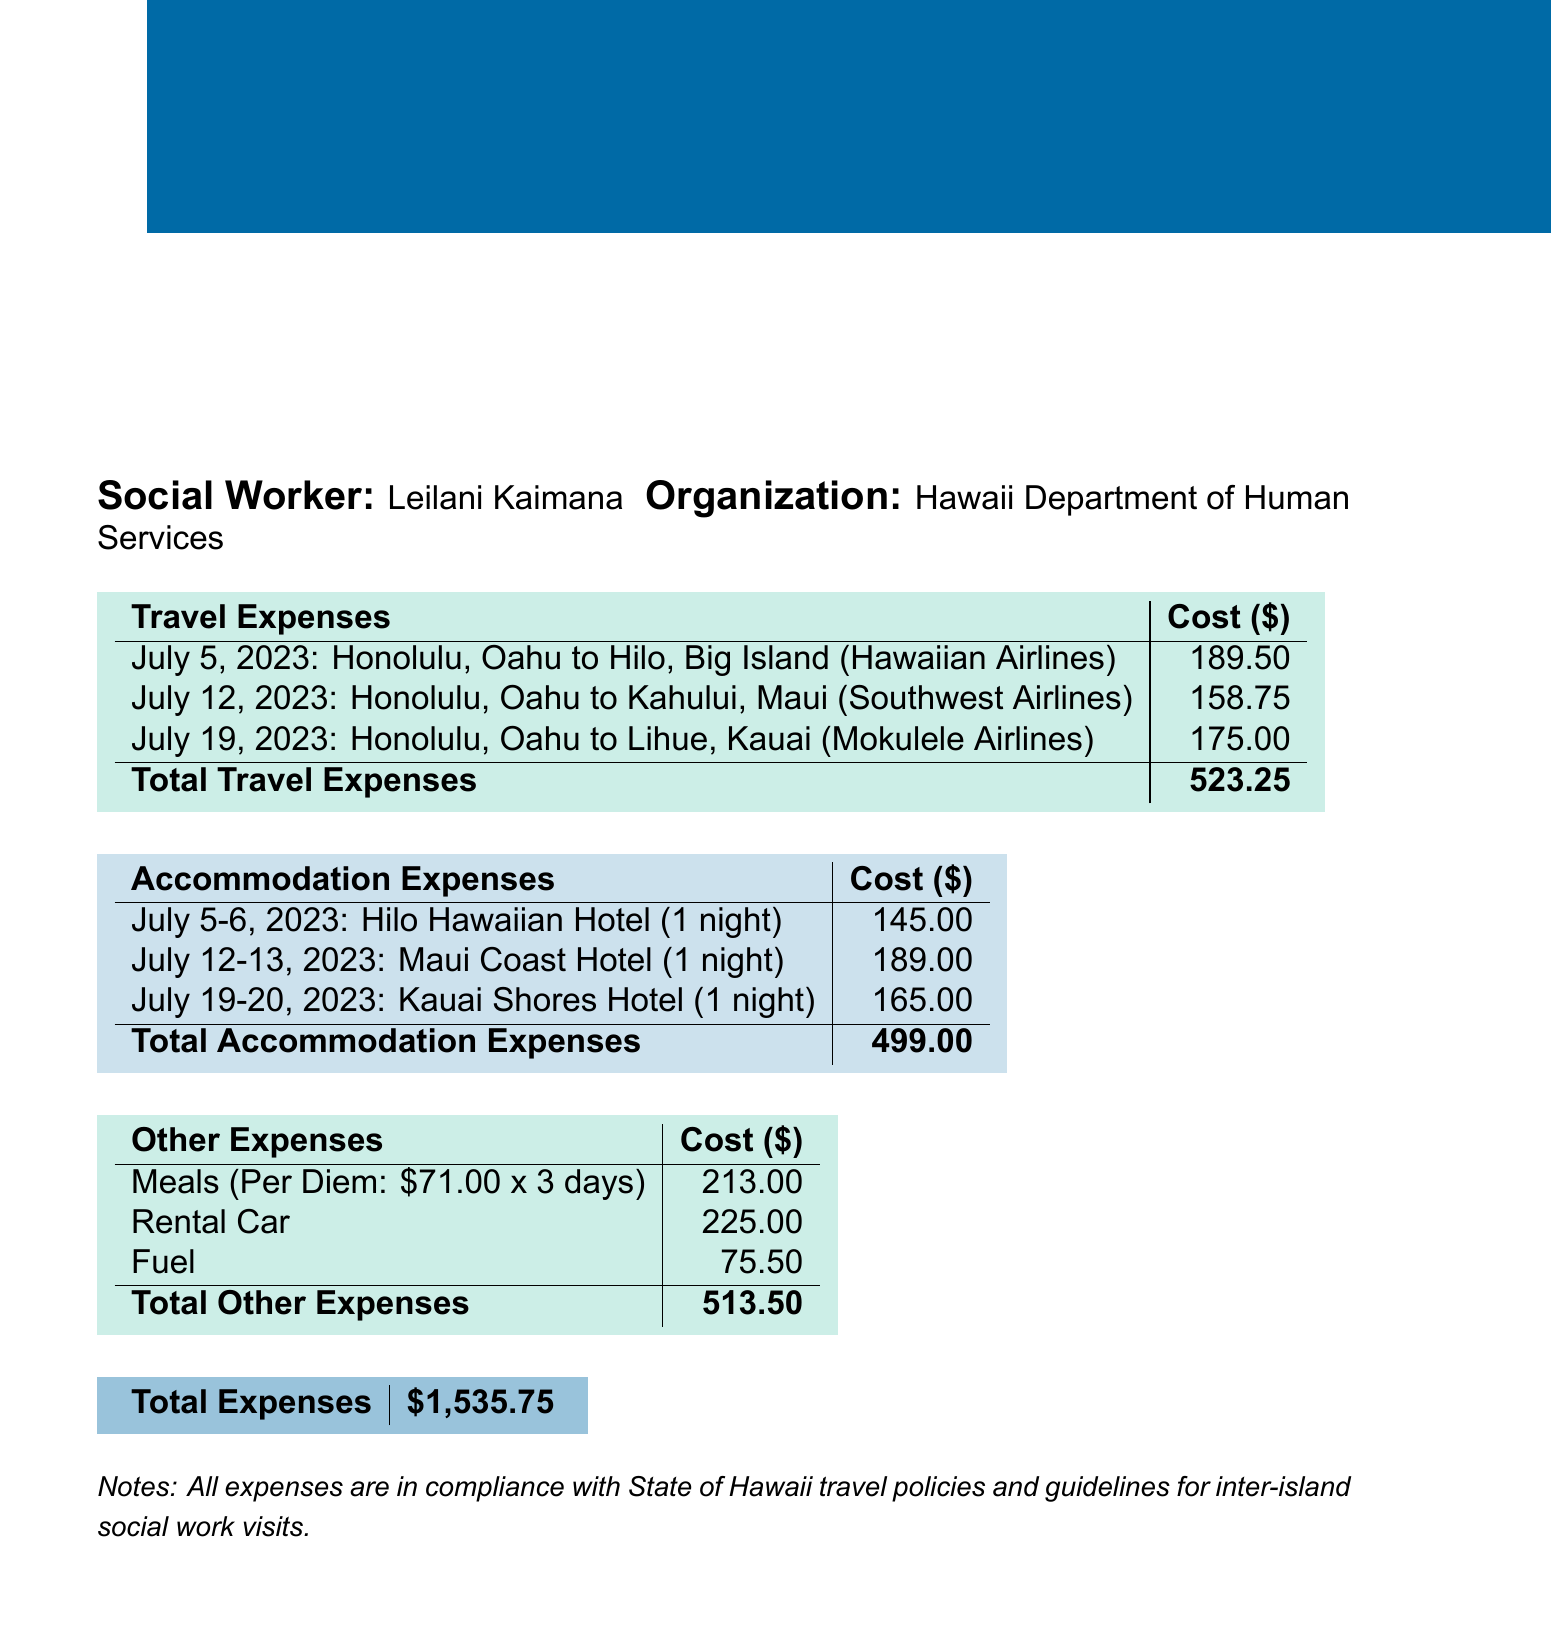what is the total travel expense? The total travel expense is calculated by summing up all the individual flight costs listed in the travel expenses section.
Answer: 523.25 how many nights did the accommodation in Maui Coast Hotel cover? The accommodation at Maui Coast Hotel covered 1 night as stated in the accommodation expenses section.
Answer: 1 what is the per diem meal rate? The per diem meal rate mentioned in the document is listed explicitly in the meal expenses section.
Answer: 71.00 how much was spent on fuel? The fuel cost is explicitly mentioned in the ground transportation section as part of the total expenses.
Answer: 75.50 what is the total expense for the report period? The total expense is the final amount calculated at the bottom of the document and includes all types of costs.
Answer: 1535.75 how many days did the social worker travel for meals? The total days for which meals were accounted for is noted in the meal expenses section under total days.
Answer: 3 what was the flight cost from Honolulu to Hilo? The flight cost for the specific trip from Honolulu to Hilo is clearly stated in the travel expenses section.
Answer: 189.50 which hotel was used for accommodation on July 19-20? The accommodation on these dates is specified in the accommodation expenses section, indicating the hotel name.
Answer: Kauai Shores Hotel are all expenses compliant with travel policies? The document includes a note indicating all expenses adhered to the stated guidelines, directly answering the compliance question.
Answer: Yes 